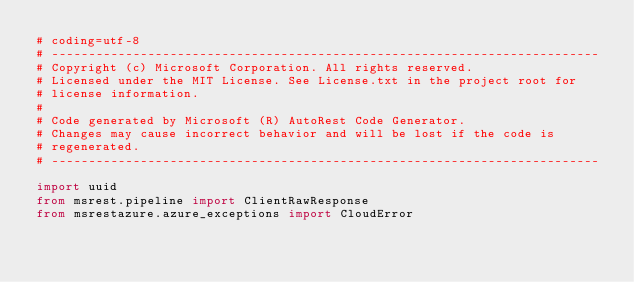<code> <loc_0><loc_0><loc_500><loc_500><_Python_># coding=utf-8
# --------------------------------------------------------------------------
# Copyright (c) Microsoft Corporation. All rights reserved.
# Licensed under the MIT License. See License.txt in the project root for
# license information.
#
# Code generated by Microsoft (R) AutoRest Code Generator.
# Changes may cause incorrect behavior and will be lost if the code is
# regenerated.
# --------------------------------------------------------------------------

import uuid
from msrest.pipeline import ClientRawResponse
from msrestazure.azure_exceptions import CloudError</code> 